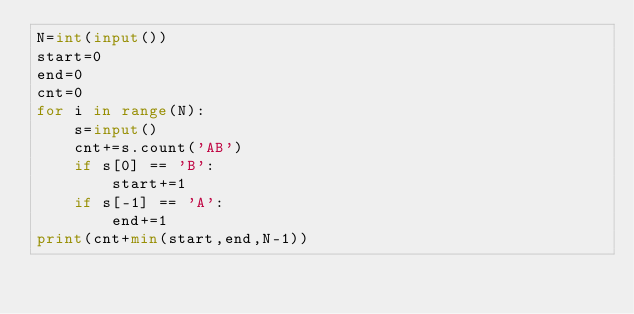Convert code to text. <code><loc_0><loc_0><loc_500><loc_500><_Python_>N=int(input())
start=0
end=0
cnt=0
for i in range(N):
    s=input()
    cnt+=s.count('AB')
    if s[0] == 'B':
        start+=1
    if s[-1] == 'A':
        end+=1
print(cnt+min(start,end,N-1))
</code> 